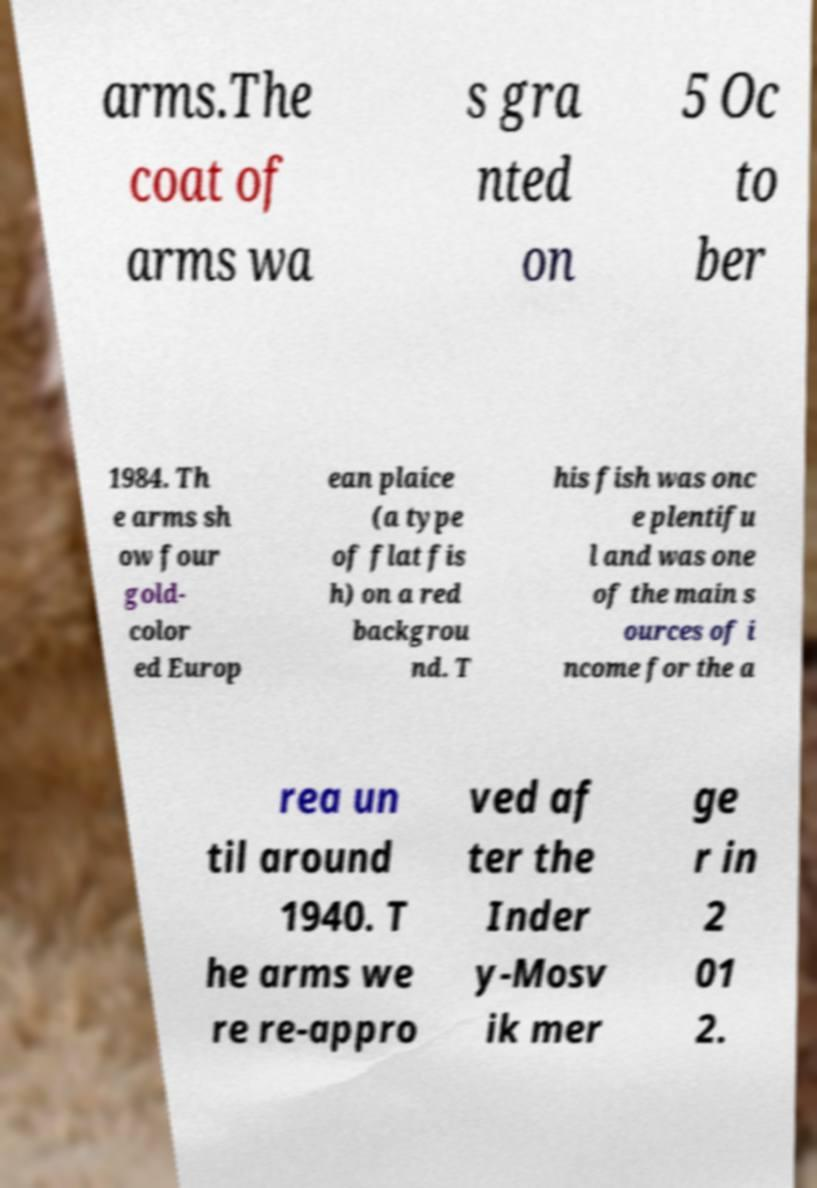Could you extract and type out the text from this image? arms.The coat of arms wa s gra nted on 5 Oc to ber 1984. Th e arms sh ow four gold- color ed Europ ean plaice (a type of flat fis h) on a red backgrou nd. T his fish was onc e plentifu l and was one of the main s ources of i ncome for the a rea un til around 1940. T he arms we re re-appro ved af ter the Inder y-Mosv ik mer ge r in 2 01 2. 